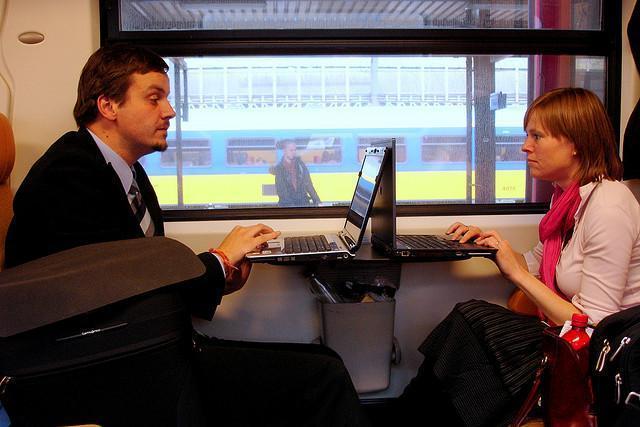How many trains are in the photo?
Give a very brief answer. 2. How many people are there?
Give a very brief answer. 2. How many laptops are visible?
Give a very brief answer. 2. How many handbags are there?
Give a very brief answer. 2. 